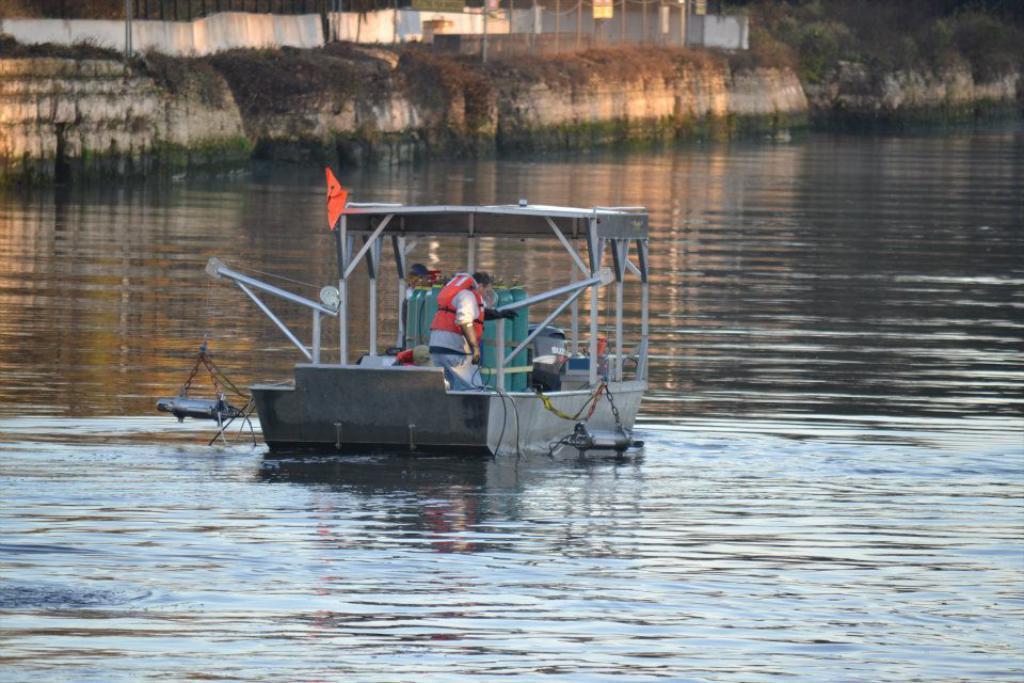How would you summarize this image in a sentence or two? In this image we can see some people standing in a boat which is on the water. On the backside we can see a wall, poles, a fence and a group of trees. 